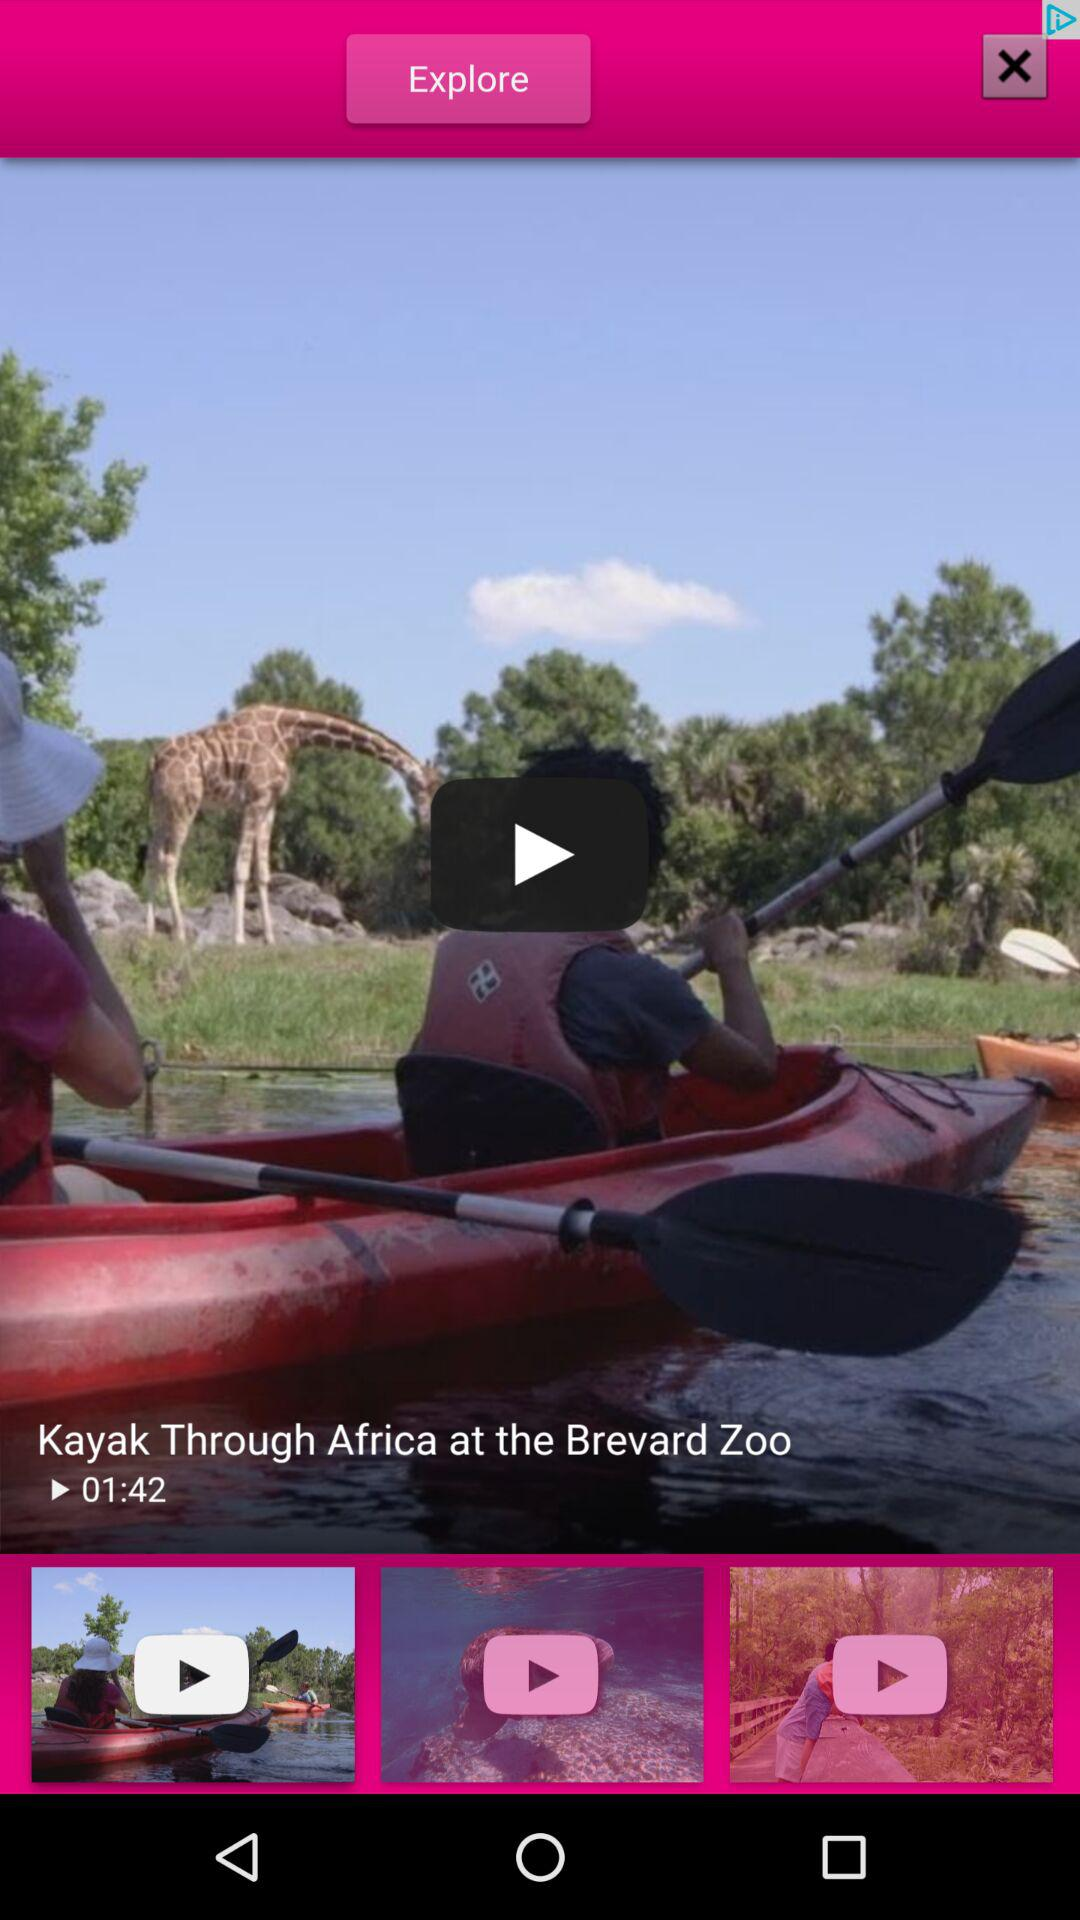How long is the video? The video is 1 minute and 42 seconds long. 